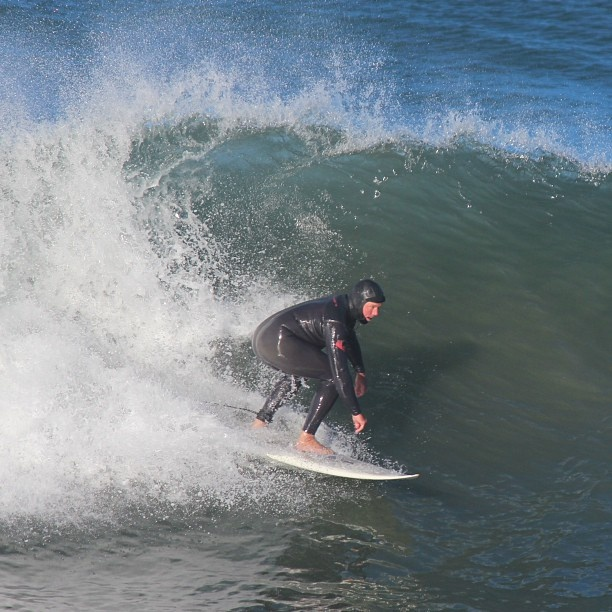Describe the objects in this image and their specific colors. I can see people in gray, black, and darkgray tones and surfboard in gray, lightgray, and darkgray tones in this image. 